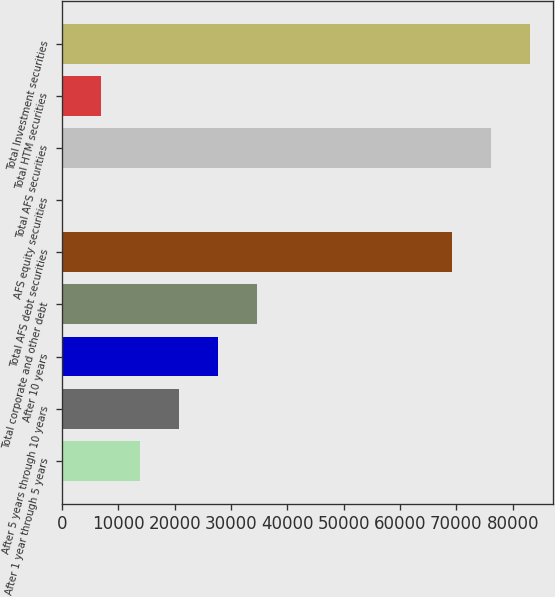Convert chart. <chart><loc_0><loc_0><loc_500><loc_500><bar_chart><fcel>After 1 year through 5 years<fcel>After 5 years through 10 years<fcel>After 10 years<fcel>Total corporate and other debt<fcel>Total AFS debt securities<fcel>AFS equity securities<fcel>Total AFS securities<fcel>Total HTM securities<fcel>Total Investment securities<nl><fcel>13872<fcel>20802.5<fcel>27733<fcel>34663.5<fcel>69205<fcel>11<fcel>76135.5<fcel>6941.5<fcel>83066<nl></chart> 